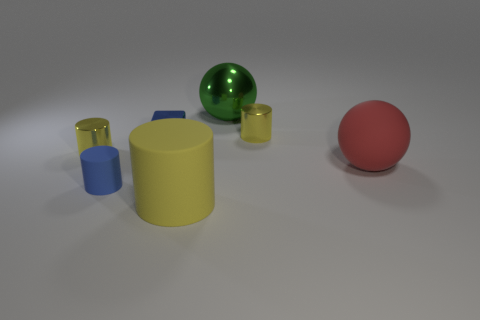How many yellow cylinders must be subtracted to get 1 yellow cylinders? 2 Subtract all green balls. How many yellow cylinders are left? 3 Subtract all green cylinders. Subtract all cyan blocks. How many cylinders are left? 4 Add 1 yellow cylinders. How many objects exist? 8 Subtract all blocks. How many objects are left? 6 Add 4 cyan things. How many cyan things exist? 4 Subtract 0 brown blocks. How many objects are left? 7 Subtract all green metal things. Subtract all red objects. How many objects are left? 5 Add 3 green objects. How many green objects are left? 4 